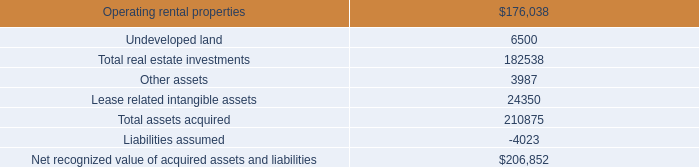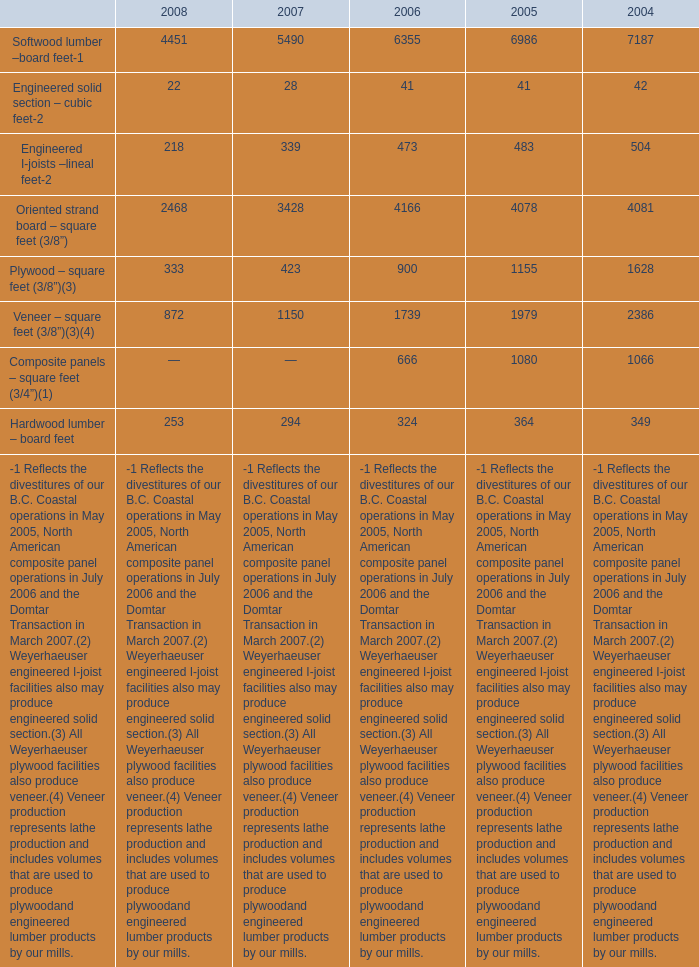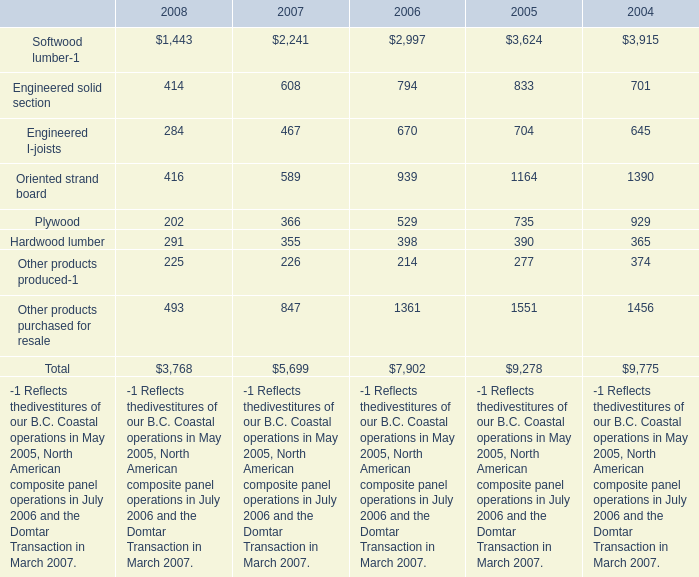Which year is Softwood lumber-1 greater than 3000 ? 
Answer: 2004 2005. 